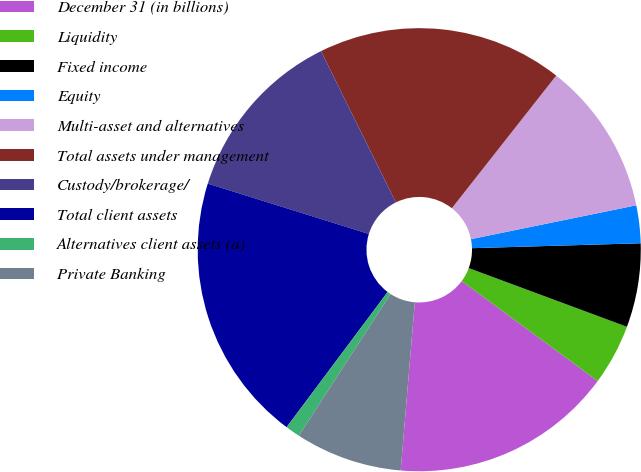<chart> <loc_0><loc_0><loc_500><loc_500><pie_chart><fcel>December 31 (in billions)<fcel>Liquidity<fcel>Fixed income<fcel>Equity<fcel>Multi-asset and alternatives<fcel>Total assets under management<fcel>Custody/brokerage/<fcel>Total client assets<fcel>Alternatives client assets (a)<fcel>Private Banking<nl><fcel>16.24%<fcel>4.44%<fcel>6.12%<fcel>2.75%<fcel>11.18%<fcel>17.92%<fcel>12.87%<fcel>19.61%<fcel>1.07%<fcel>7.81%<nl></chart> 